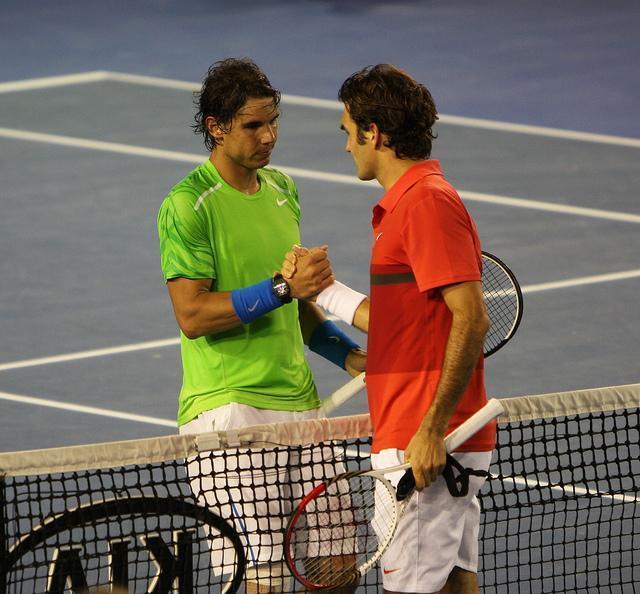How many people can you see?
Give a very brief answer. 2. How many tennis rackets can be seen?
Give a very brief answer. 2. 